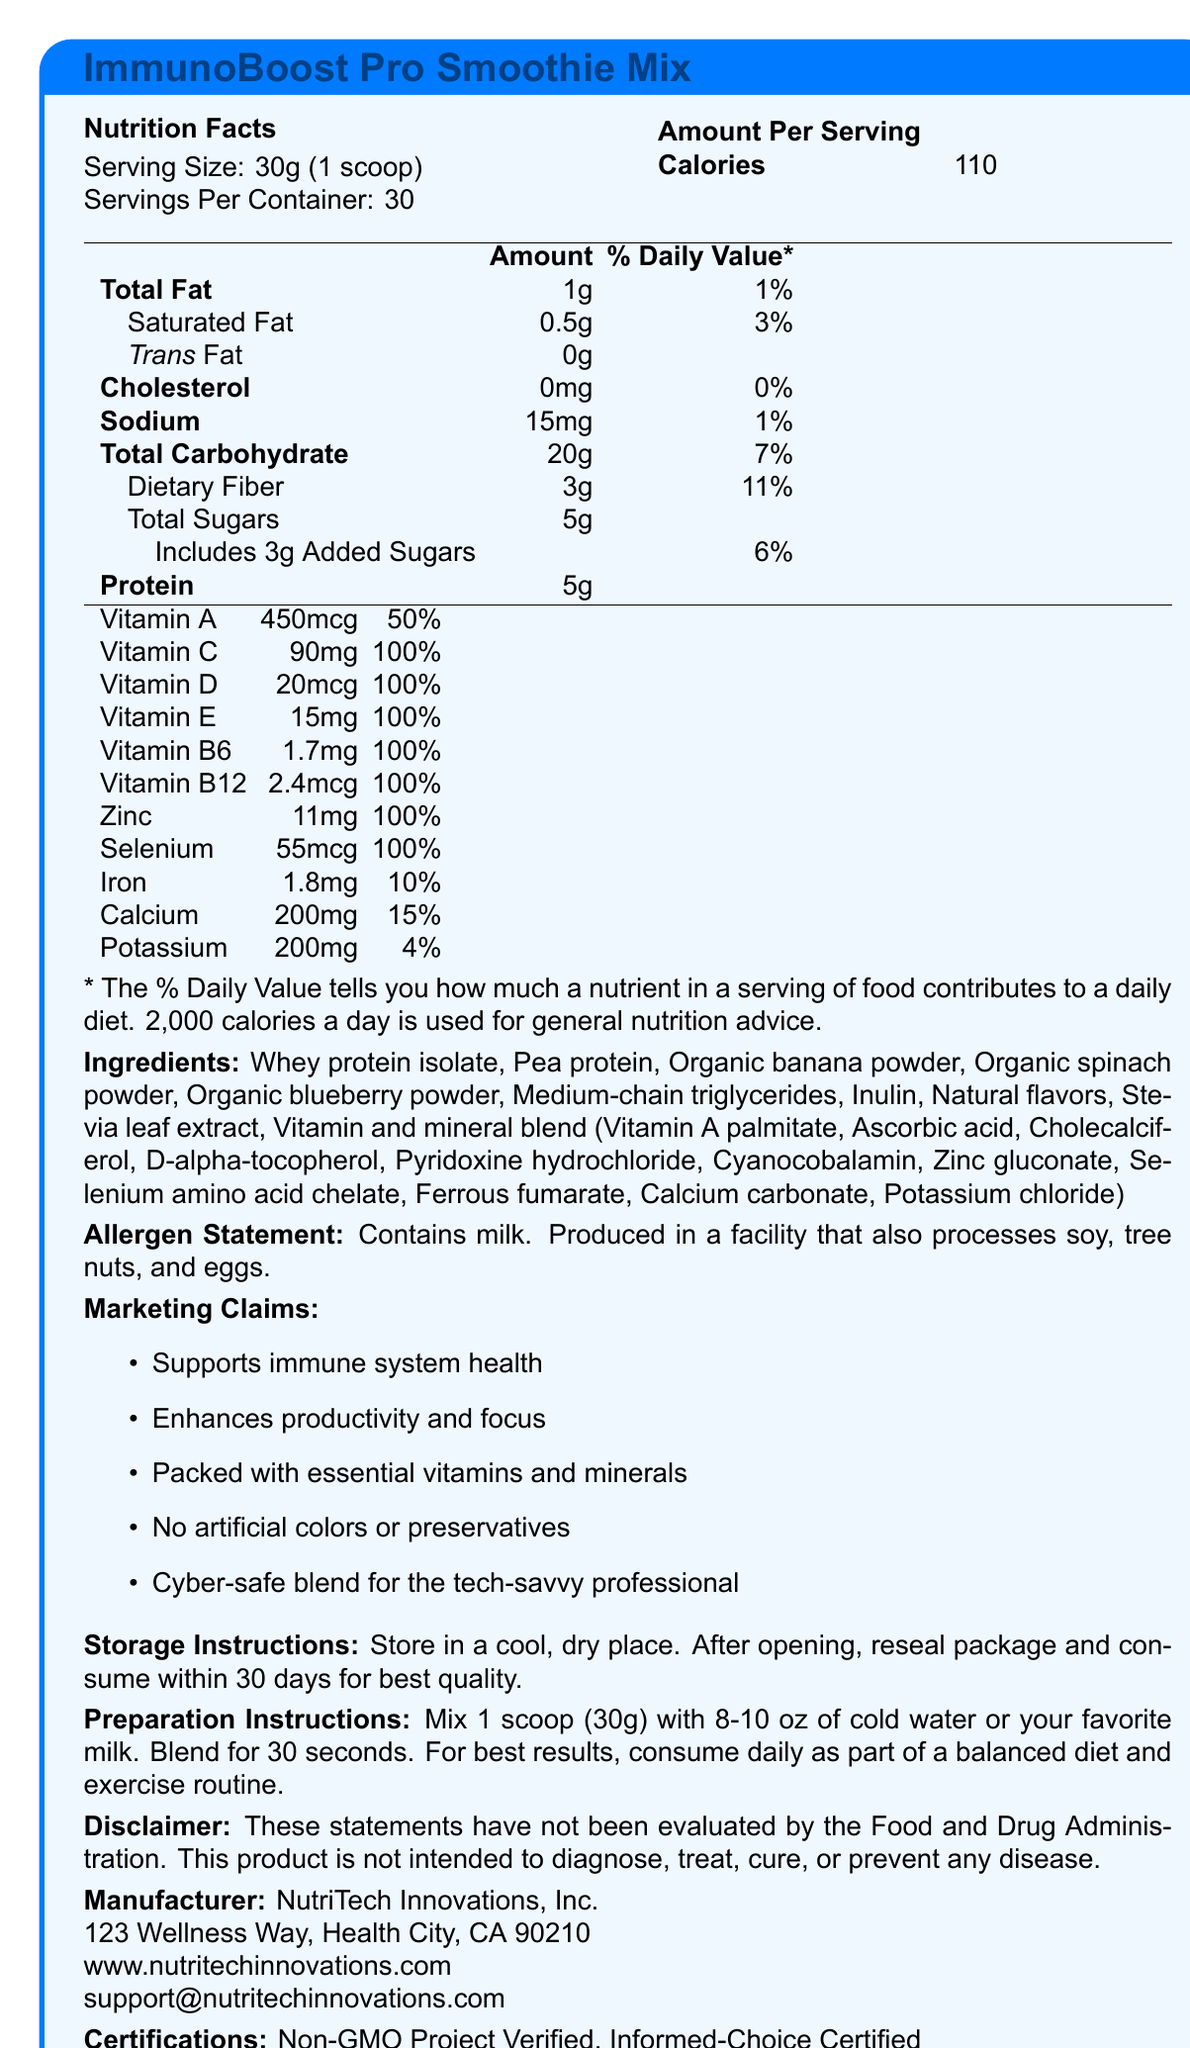what is the serving size of the ImmunoBoost Pro Smoothie Mix? The serving size is clearly labeled in the nutrition facts part of the document under "Serving Size".
Answer: 30g (1 scoop) How many calories are in one serving of the smoothie mix? The amount of calories per serving is explicitly mentioned under the nutrition facts section next to "Calories".
Answer: 110 What is the total amount of fat in one serving? The total fat content per serving can be found in the nutrition facts, labeled as "Total Fat".
Answer: 1g How much dietary fiber does the product contain per serving? The dietary fiber content is listed under the "Total Carbohydrate" section in the nutrition facts.
Answer: 3g What is the percentage of daily value for Vitamin C per serving? The percentage of daily value for Vitamin C is given in the micronutrients section of the nutrition facts as "100%".
Answer: 100% What allergens does the product contain? A. Soy B. Peanuts C. Milk D. Gluten The allergen statement in the document specifies that the product contains milk.
Answer: C. Milk Which ingredient is NOT listed in the ImmunoBoost Pro Smoothie Mix? A. Organic blueberry powder B. Stevia leaf extract C. Artificial flavors D. Inulin The ingredients list clearly shows "Stevia leaf extract" and "Inulin," but not "Artificial flavors".
Answer: C. Artificial flavors What is the storage instruction for the product? The storage instructions are provided in the document under the section labeled "Storage Instructions".
Answer: Store in a cool, dry place. After opening, reseal package and consume within 30 days for best quality. Does the product contain any added sugars? The nutrition facts clearly state "Includes 3g Added Sugars" under the total sugars.
Answer: Yes Does the document include the company's contact details? The company’s contact information including address, website, and support email is listed at the end of the document.
Answer: Yes Summarize the main idea of the document. The document focuses on presenting the nutritional and ingredient information of the product, along with details about its benefits, storage, preparation, and manufacturer information. It also emphasizes the certifications the product has received.
Answer: The ImmunoBoost Pro Smoothie Mix is a vitamin-fortified product designed to boost immune system health and productivity. It contains a variety of vitamins and minerals, provides specific serving details, includes allergen and storage instructions, and offers several health-related marketing claims. How much protein does one serving of the smoothie mix contain? The protein content per serving is listed under the nutritional facts as "Protein".
Answer: 5g Which vitamins are all provided at 100% of the daily value per serving? I. Vitamin B6 II. Vitamin D III. Vitamin E IV. Vitamin A Vitamin B6, Vitamin D, and Vitamin E are each listed at 100% of the daily value per serving while Vitamin A is listed at 50%.
Answer: I, II, III What is the main benefit highlighted about the ImmunoBoost Pro Smoothie Mix? One of the key marketing claims listed in the document is "Supports immune system health".
Answer: Supports immune system health What is the sodium content per serving? The sodium content per serving is labeled under the nutrition facts in the section for sodium.
Answer: 15mg What position would "Contains milk" occupy if sorted alphabetically within the Allergen Statement? The sorting mechanism for a specific part of a text like the allergen statement is not provided within the visual document; it cannot be determined from the given data.
Answer: Not enough information 